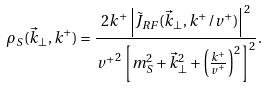Convert formula to latex. <formula><loc_0><loc_0><loc_500><loc_500>\rho _ { S } ( { \vec { k } } _ { \perp } , k ^ { + } ) = \frac { 2 k ^ { + } \left | \tilde { J } _ { R F } ( { \vec { k } } _ { \perp } , k ^ { + } / v ^ { + } ) \right | ^ { 2 } } { { v ^ { + } } ^ { 2 } \left [ m _ { S } ^ { 2 } + { \vec { k } } _ { \perp } ^ { 2 } + \left ( \frac { k ^ { + } } { v ^ { + } } \right ) ^ { 2 } \right ] ^ { 2 } } .</formula> 